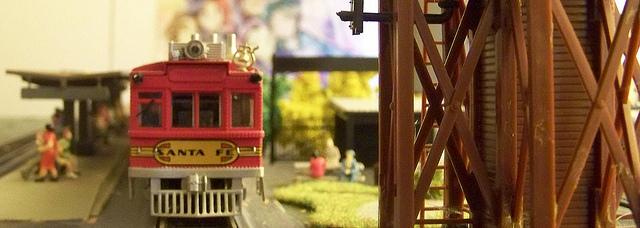What color is the train?
Answer briefly. Red. Where is the platform?
Give a very brief answer. Next to train. Is that a toy train?
Be succinct. Yes. 